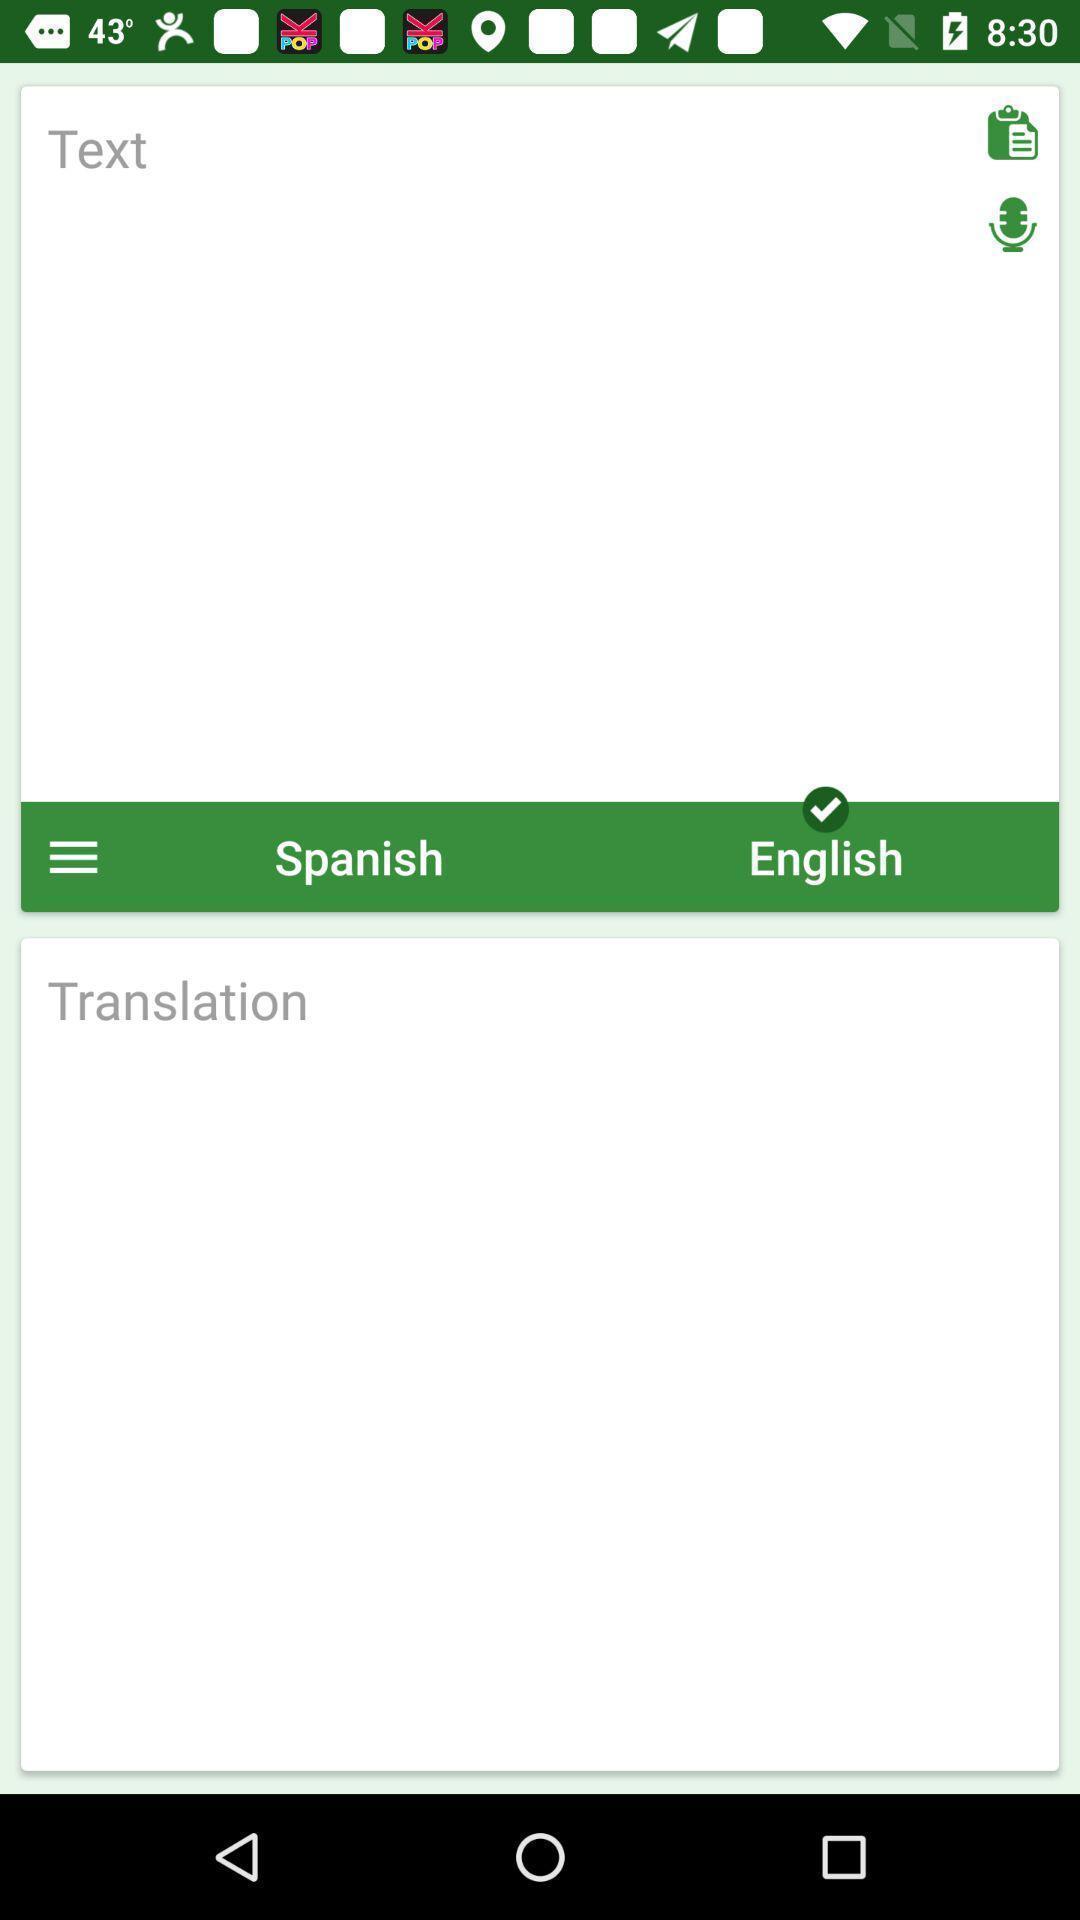Explain the elements present in this screenshot. Translation page is being displayed in the app. 